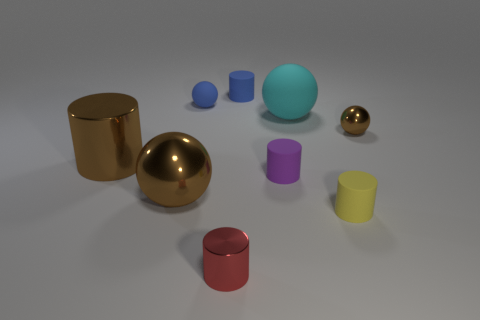Add 1 large blue metal cylinders. How many objects exist? 10 Subtract all purple rubber cylinders. How many cylinders are left? 4 Subtract all blue blocks. How many brown balls are left? 2 Subtract all blue cylinders. How many cylinders are left? 4 Subtract all cylinders. How many objects are left? 4 Subtract 4 spheres. How many spheres are left? 0 Subtract all green cylinders. Subtract all purple balls. How many cylinders are left? 5 Subtract all cyan things. Subtract all small yellow rubber objects. How many objects are left? 7 Add 4 metallic cylinders. How many metallic cylinders are left? 6 Add 2 blue matte balls. How many blue matte balls exist? 3 